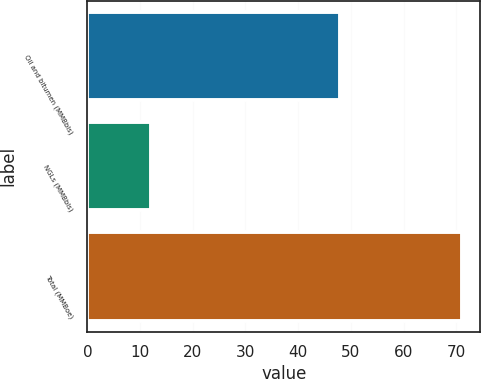<chart> <loc_0><loc_0><loc_500><loc_500><bar_chart><fcel>Oil and bitumen (MMBbls)<fcel>NGLs (MMBbls)<fcel>Total (MMBoe)<nl><fcel>48<fcel>12<fcel>71<nl></chart> 